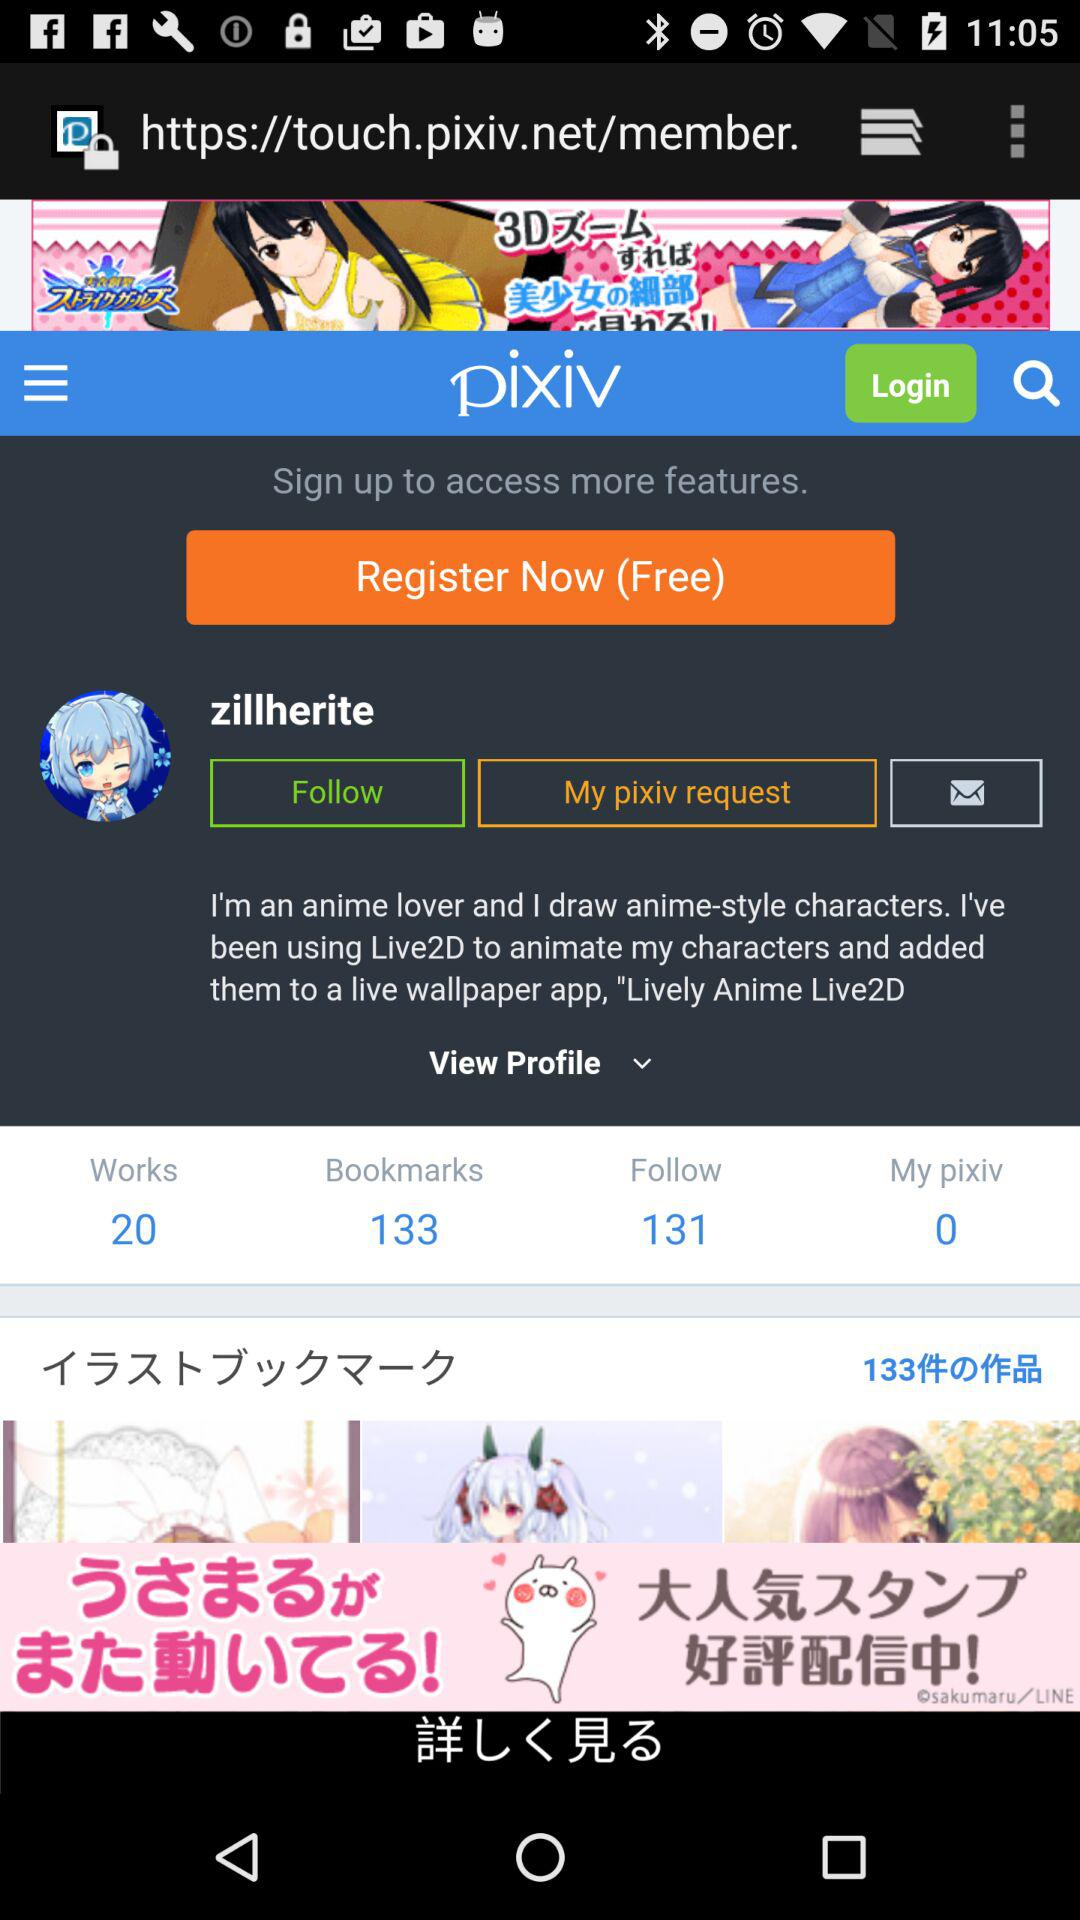How many bookmarks are there? There are 133 bookmarks. 